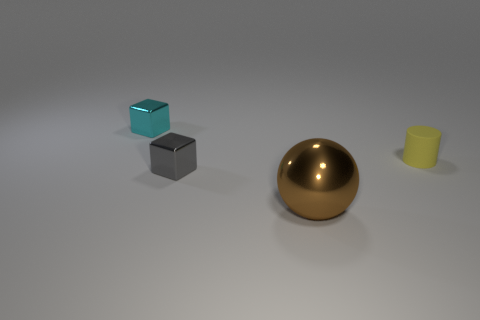There is a thing that is both behind the brown ball and in front of the small yellow cylinder; what size is it?
Ensure brevity in your answer.  Small. How many metallic things are brown objects or tiny objects?
Your response must be concise. 3. What material is the gray object?
Ensure brevity in your answer.  Metal. What is the small block on the right side of the small cube that is behind the small metal thing that is in front of the cylinder made of?
Give a very brief answer. Metal. What shape is the yellow object that is the same size as the gray cube?
Offer a very short reply. Cylinder. What number of things are either yellow cylinders or small things in front of the small rubber object?
Your answer should be compact. 2. Do the cube left of the gray block and the object that is on the right side of the large metallic thing have the same material?
Give a very brief answer. No. What number of cyan things are spheres or small rubber objects?
Keep it short and to the point. 0. The brown object has what size?
Offer a very short reply. Large. Are there more small gray objects in front of the large brown object than spheres?
Keep it short and to the point. No. 